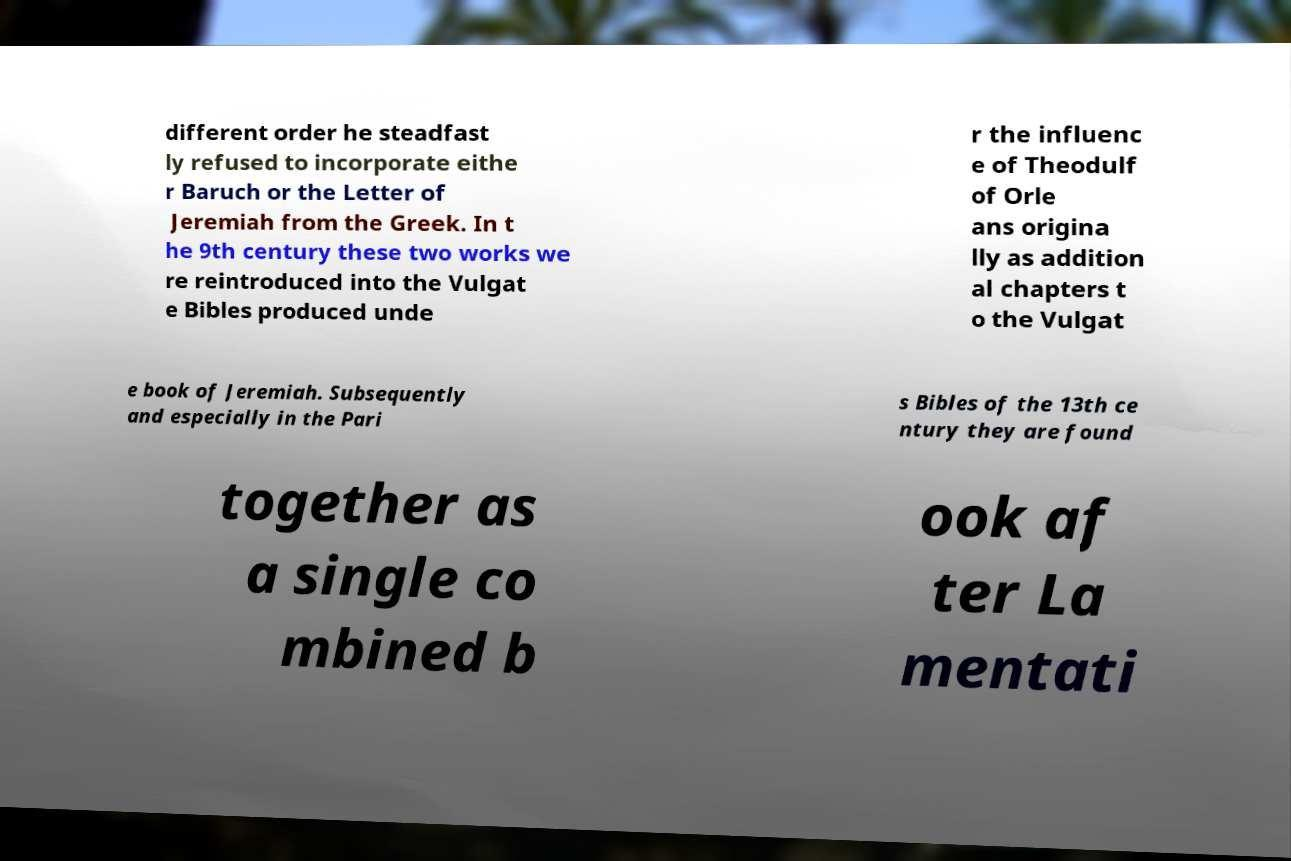Could you extract and type out the text from this image? different order he steadfast ly refused to incorporate eithe r Baruch or the Letter of Jeremiah from the Greek. In t he 9th century these two works we re reintroduced into the Vulgat e Bibles produced unde r the influenc e of Theodulf of Orle ans origina lly as addition al chapters t o the Vulgat e book of Jeremiah. Subsequently and especially in the Pari s Bibles of the 13th ce ntury they are found together as a single co mbined b ook af ter La mentati 